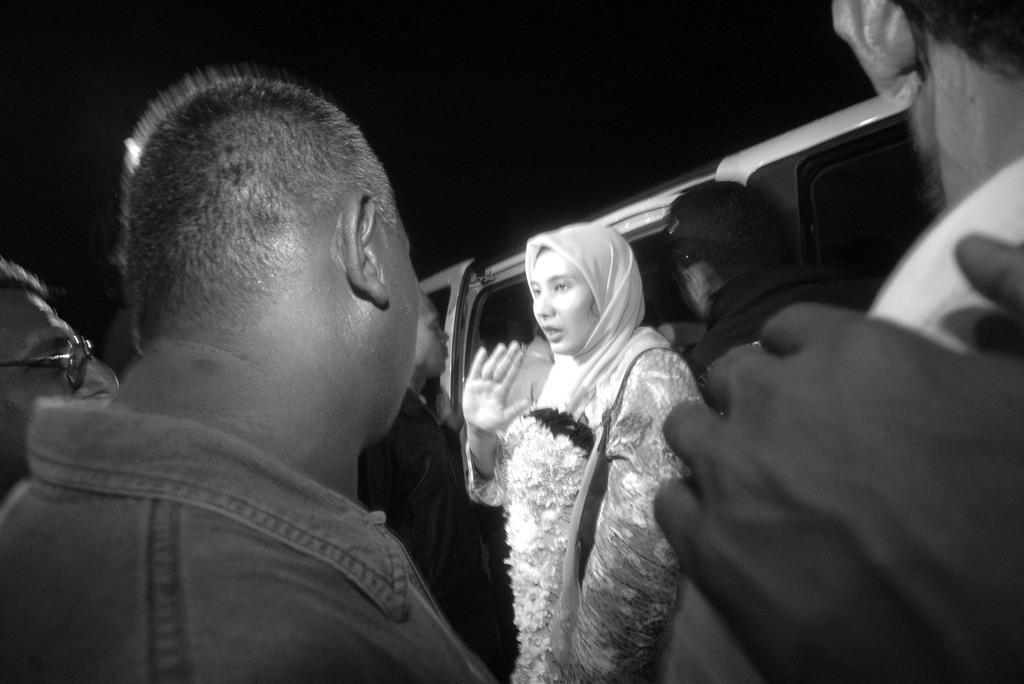What is the color scheme of the image? The image is black and white. What can be seen in the front of the image? There are persons standing in the front of the image. Who is the main subject in the middle of the image? There is an Arab woman with a garland in the middle of the image. What is the Arab woman standing in front of? The Arab woman is standing in front of a vehicle. What invention is the judge holding in the image? There is no judge present in the image, and therefore no invention can be observed. What type of line is visible in the image? There is no line visible in the image. 